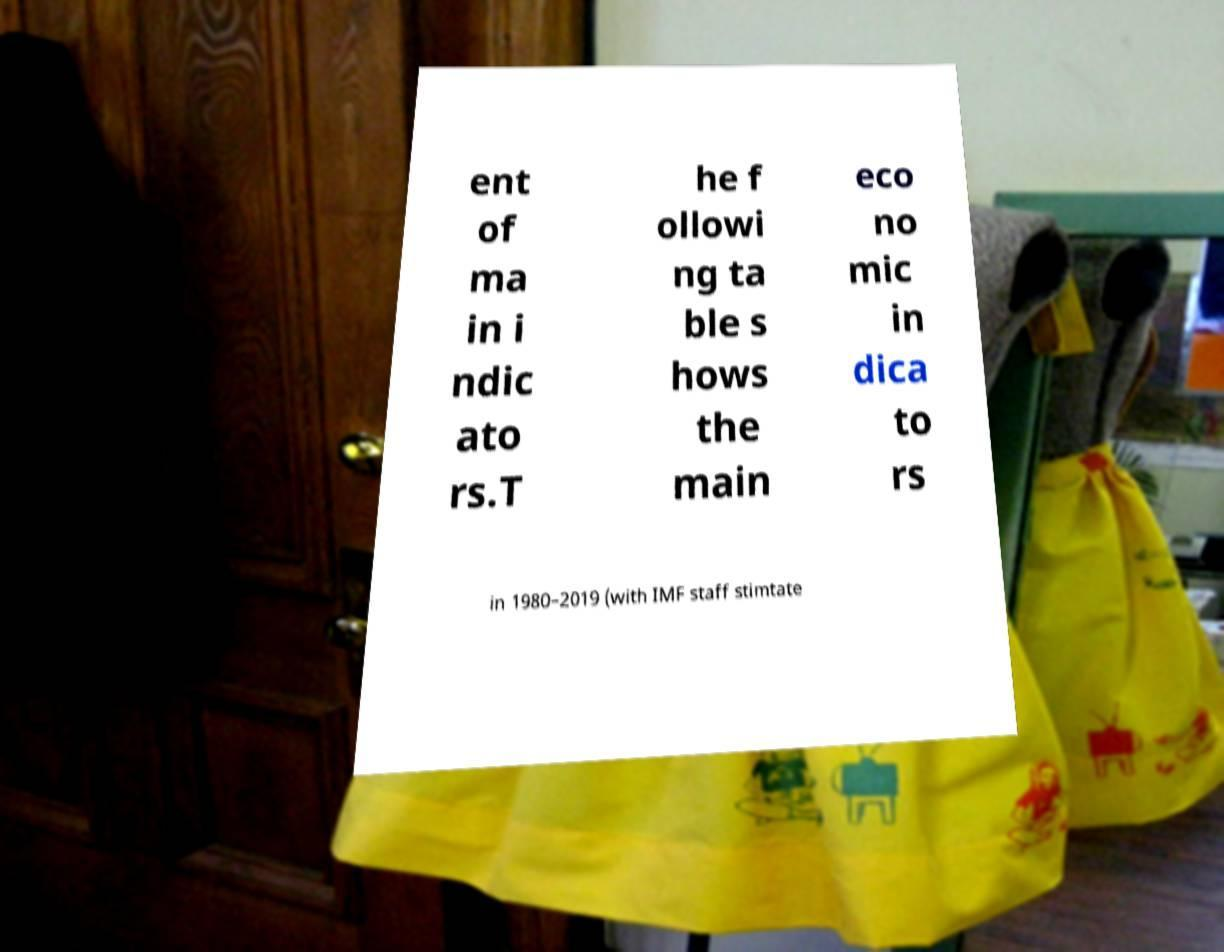Can you accurately transcribe the text from the provided image for me? ent of ma in i ndic ato rs.T he f ollowi ng ta ble s hows the main eco no mic in dica to rs in 1980–2019 (with IMF staff stimtate 